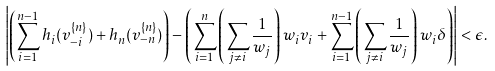<formula> <loc_0><loc_0><loc_500><loc_500>\left | \left ( \sum _ { i = 1 } ^ { n - 1 } h _ { i } ( v ^ { \{ n \} } _ { - i } ) + h _ { n } ( v ^ { \{ n \} } _ { - n } ) \right ) - \left ( \sum _ { i = 1 } ^ { n } \left ( \sum _ { j \neq i } \frac { 1 } { w _ { j } } \right ) w _ { i } v _ { i } + \sum _ { i = 1 } ^ { n - 1 } \left ( \sum _ { j \neq i } \frac { 1 } { w _ { j } } \right ) w _ { i } \delta \right ) \right | < \epsilon .</formula> 